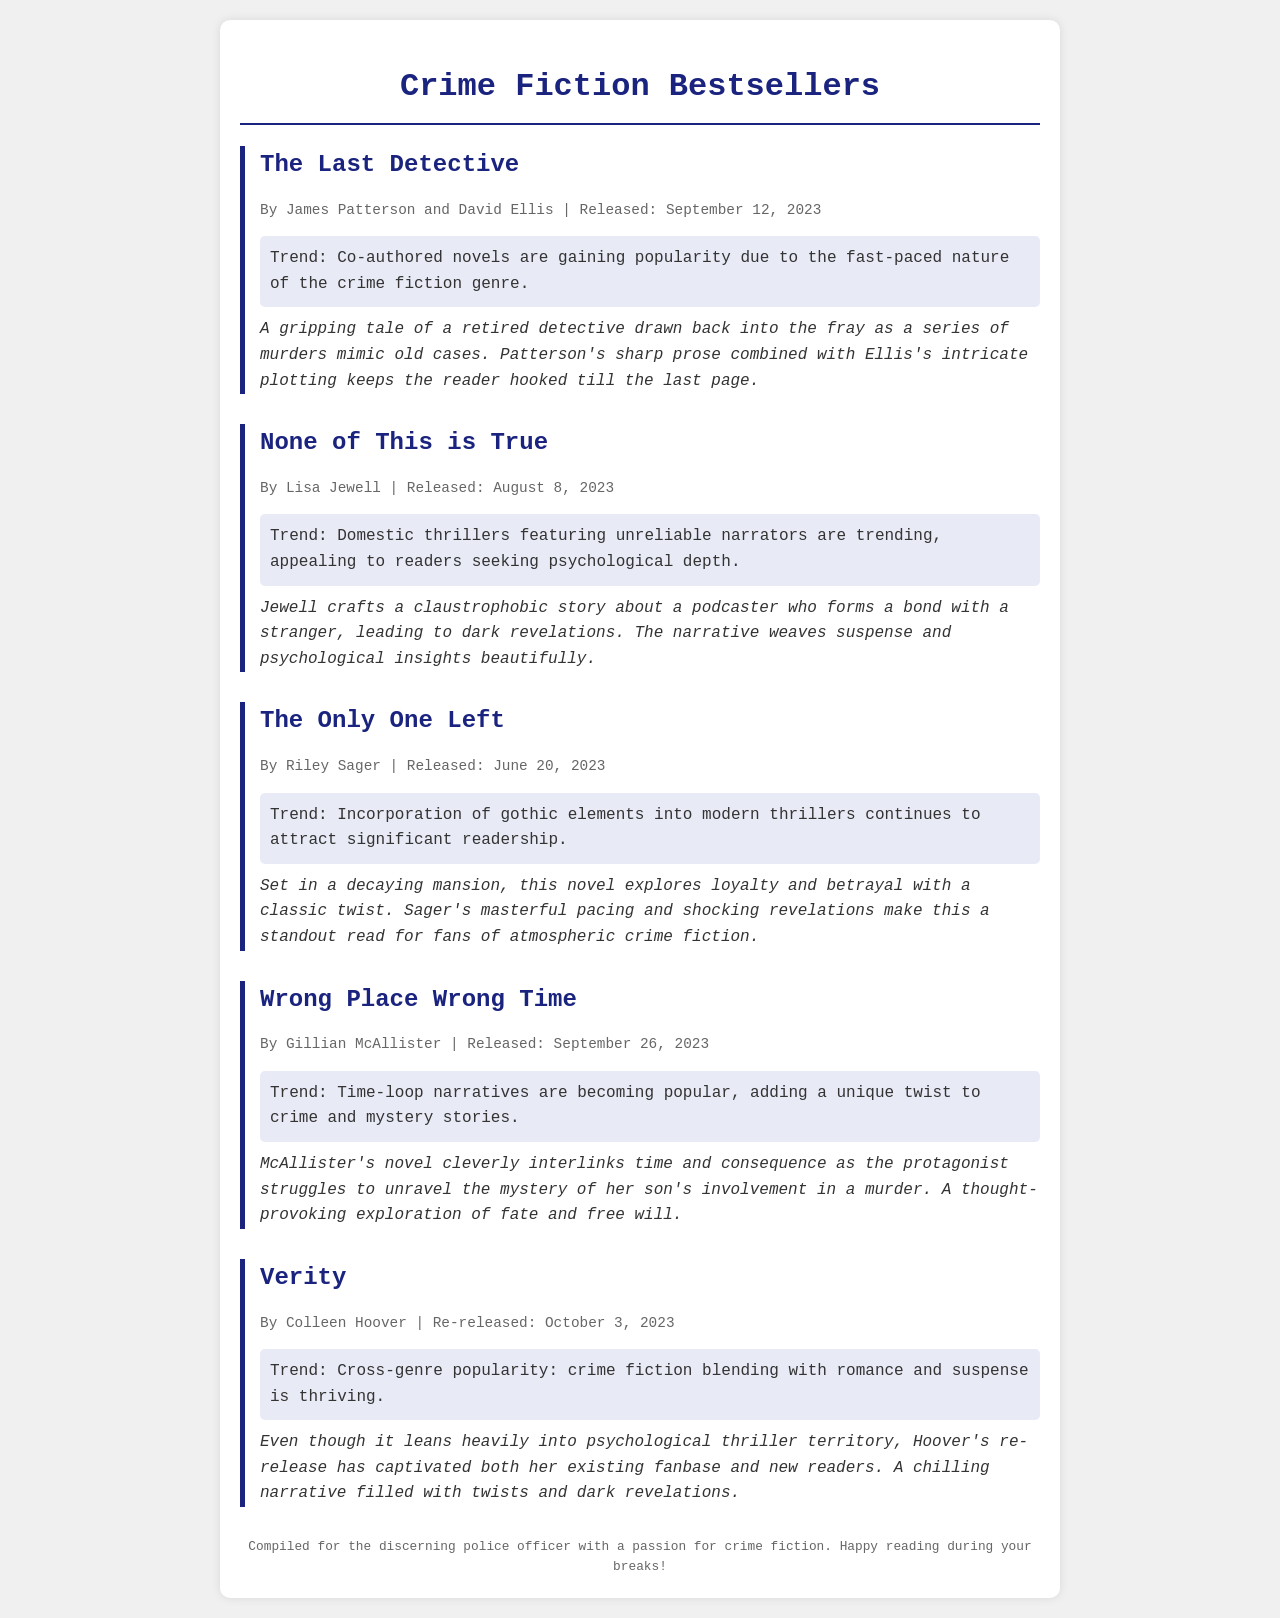What is the title of the book co-authored by James Patterson? The title is specifically mentioned as a new release in the document along with its authors.
Answer: The Last Detective Who is the author of "None of This is True"? The document provides the author's name alongside the title and release information, making it easy to identify.
Answer: Lisa Jewell When was "The Only One Left" released? The release date is clearly stated in the document under the book's information.
Answer: June 20, 2023 What trend is associated with "Wrong Place Wrong Time"? The document highlights trends for each book, specifically for "Wrong Place Wrong Time."
Answer: Time-loop narratives Which author has a re-released book featured? The document mentions various books and their authors, allowing for identification of re-releases.
Answer: Colleen Hoover What type of novels are gaining popularity according to the trend of "The Last Detective"? The trends provide insight into what types of crime fiction are currently appealing to readers.
Answer: Co-authored novels How many books are featured in the bestseller list? The document enumerates the entries, allowing for quick identification of the total number of featured books.
Answer: Five What is the main theme of "None of This is True"? The theme is inferred from the review provided for the book within the document.
Answer: Claustrophobic story about a podcaster What commonality do "The Only One Left" and "Verity" share? Both books are analyzed for their thematic content and the type of thrillers they represent in the document.
Answer: Gothic elements and psychological thriller 